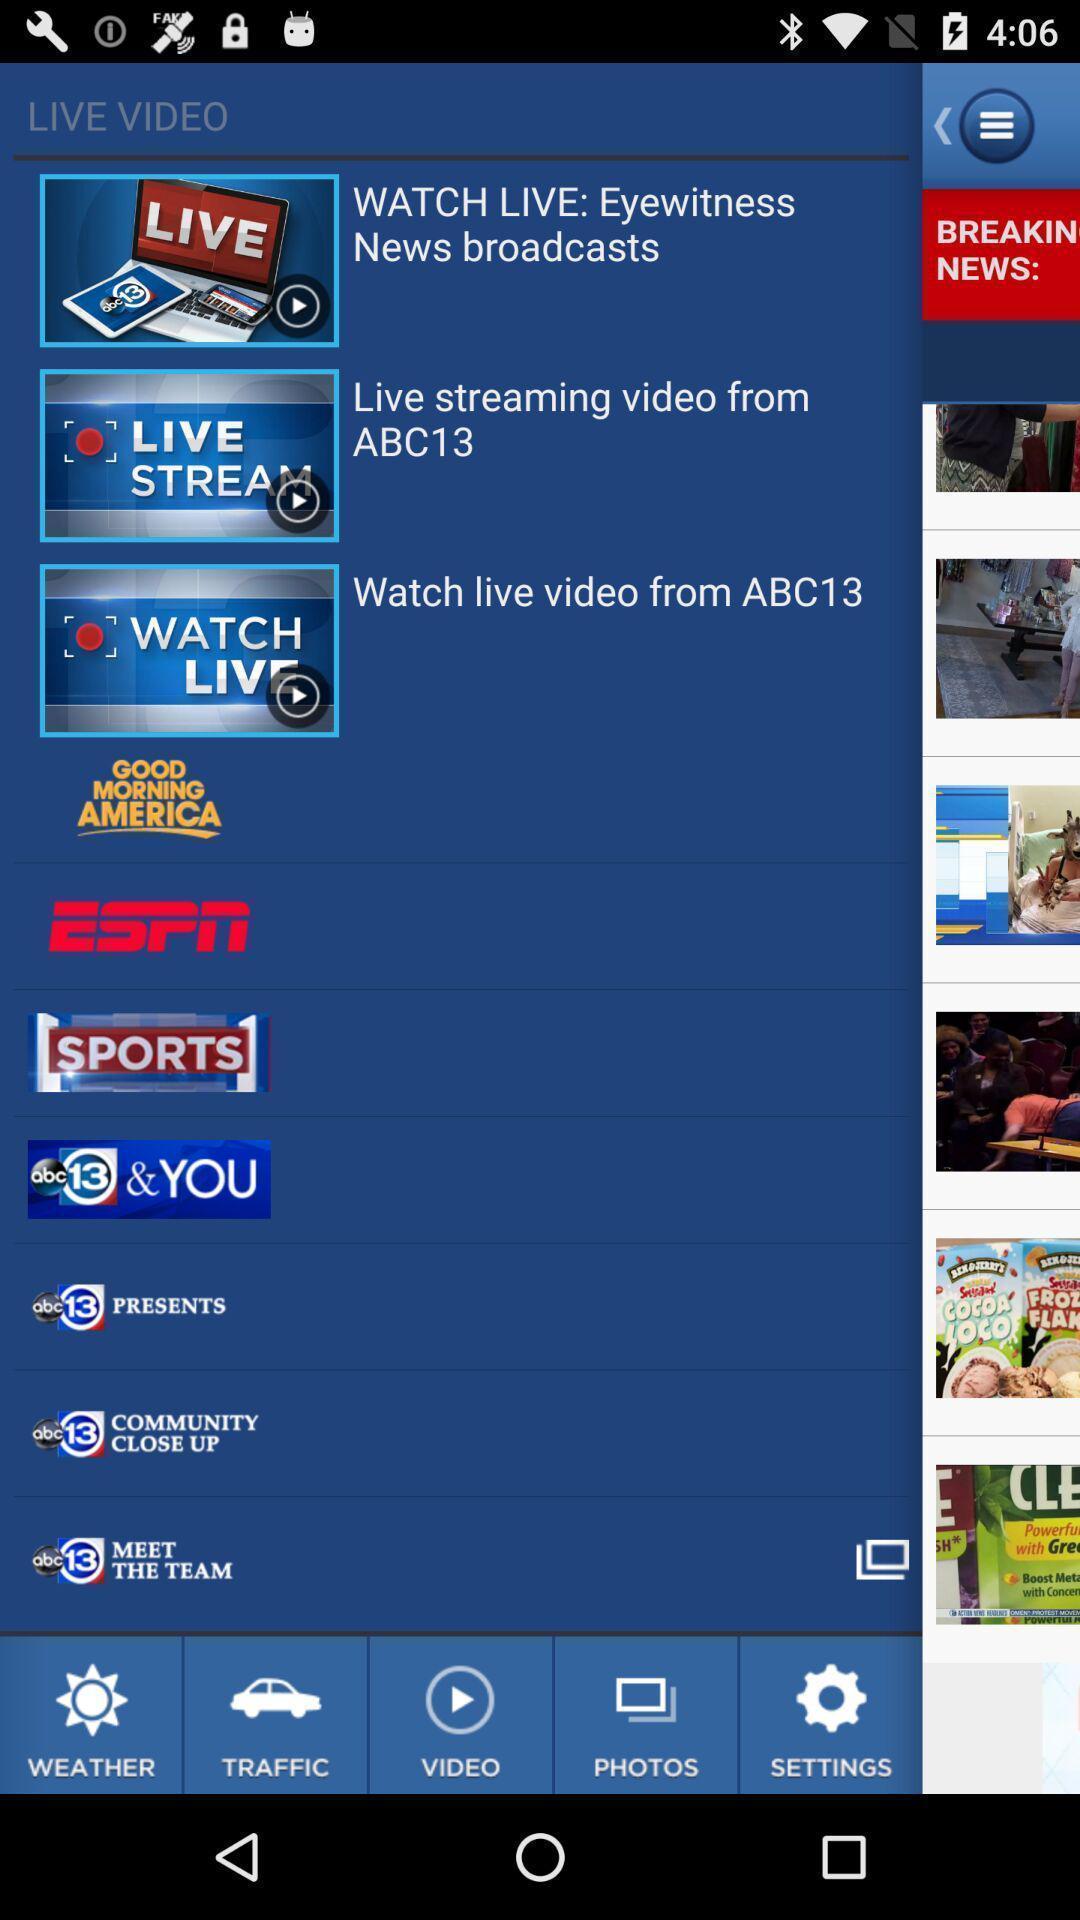Summarize the main components in this picture. Various stream videos and channels logos displayed. 